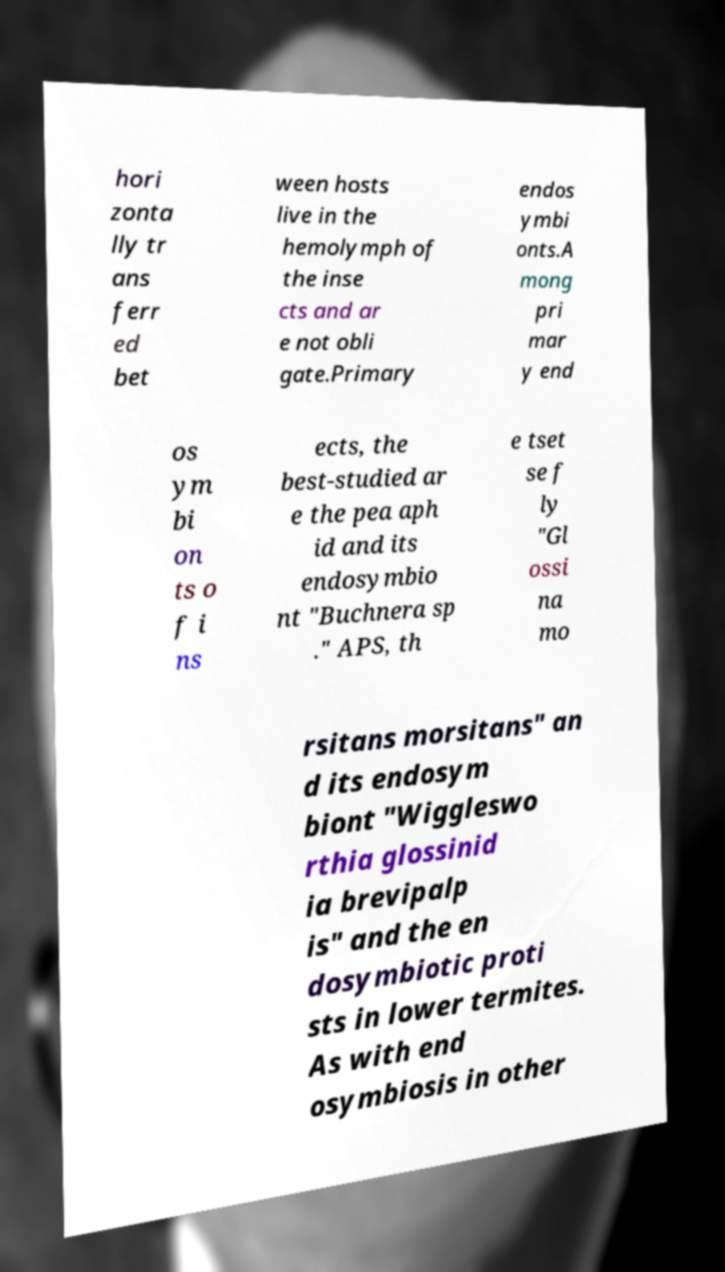Can you read and provide the text displayed in the image?This photo seems to have some interesting text. Can you extract and type it out for me? hori zonta lly tr ans ferr ed bet ween hosts live in the hemolymph of the inse cts and ar e not obli gate.Primary endos ymbi onts.A mong pri mar y end os ym bi on ts o f i ns ects, the best-studied ar e the pea aph id and its endosymbio nt "Buchnera sp ." APS, th e tset se f ly "Gl ossi na mo rsitans morsitans" an d its endosym biont "Wiggleswo rthia glossinid ia brevipalp is" and the en dosymbiotic proti sts in lower termites. As with end osymbiosis in other 